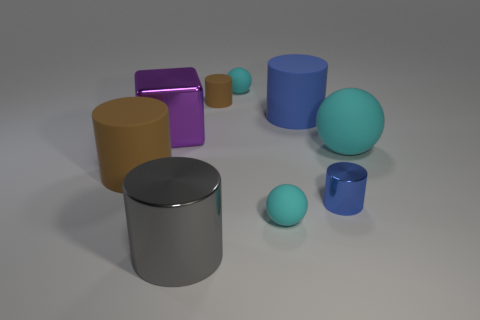Subtract all large balls. How many balls are left? 2 Add 1 tiny red matte balls. How many objects exist? 10 Subtract 4 cylinders. How many cylinders are left? 1 Subtract all gray cylinders. How many cylinders are left? 4 Subtract all brown blocks. How many red spheres are left? 0 Subtract all small cyan spheres. Subtract all large matte balls. How many objects are left? 6 Add 9 tiny brown things. How many tiny brown things are left? 10 Add 4 cyan balls. How many cyan balls exist? 7 Subtract 0 green spheres. How many objects are left? 9 Subtract all spheres. How many objects are left? 6 